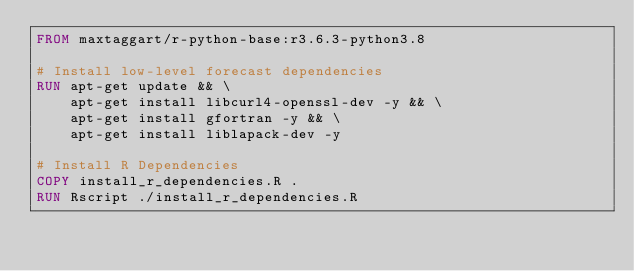<code> <loc_0><loc_0><loc_500><loc_500><_Dockerfile_>FROM maxtaggart/r-python-base:r3.6.3-python3.8

# Install low-level forecast dependencies
RUN apt-get update && \
    apt-get install libcurl4-openssl-dev -y && \
    apt-get install gfortran -y && \
    apt-get install liblapack-dev -y

# Install R Dependencies
COPY install_r_dependencies.R .
RUN Rscript ./install_r_dependencies.R</code> 